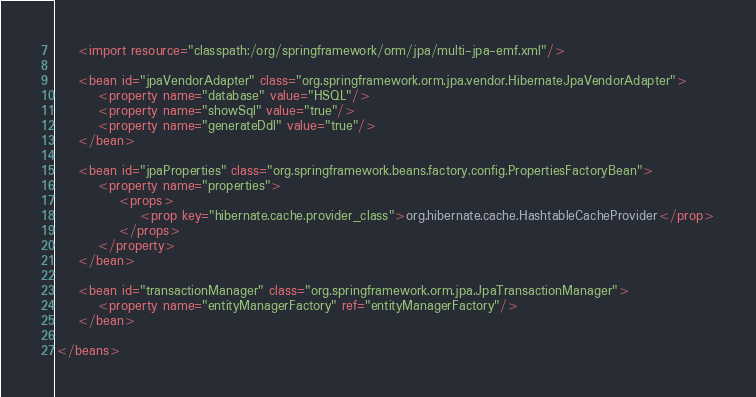Convert code to text. <code><loc_0><loc_0><loc_500><loc_500><_XML_>
	<import resource="classpath:/org/springframework/orm/jpa/multi-jpa-emf.xml"/>

	<bean id="jpaVendorAdapter" class="org.springframework.orm.jpa.vendor.HibernateJpaVendorAdapter">
		<property name="database" value="HSQL"/>
		<property name="showSql" value="true"/>
		<property name="generateDdl" value="true"/>
	</bean>

	<bean id="jpaProperties" class="org.springframework.beans.factory.config.PropertiesFactoryBean">
		<property name="properties">
			<props>
				<prop key="hibernate.cache.provider_class">org.hibernate.cache.HashtableCacheProvider</prop>
			</props>
		</property>
	</bean>

	<bean id="transactionManager" class="org.springframework.orm.jpa.JpaTransactionManager">
		<property name="entityManagerFactory" ref="entityManagerFactory"/>
	</bean>

</beans>
</code> 